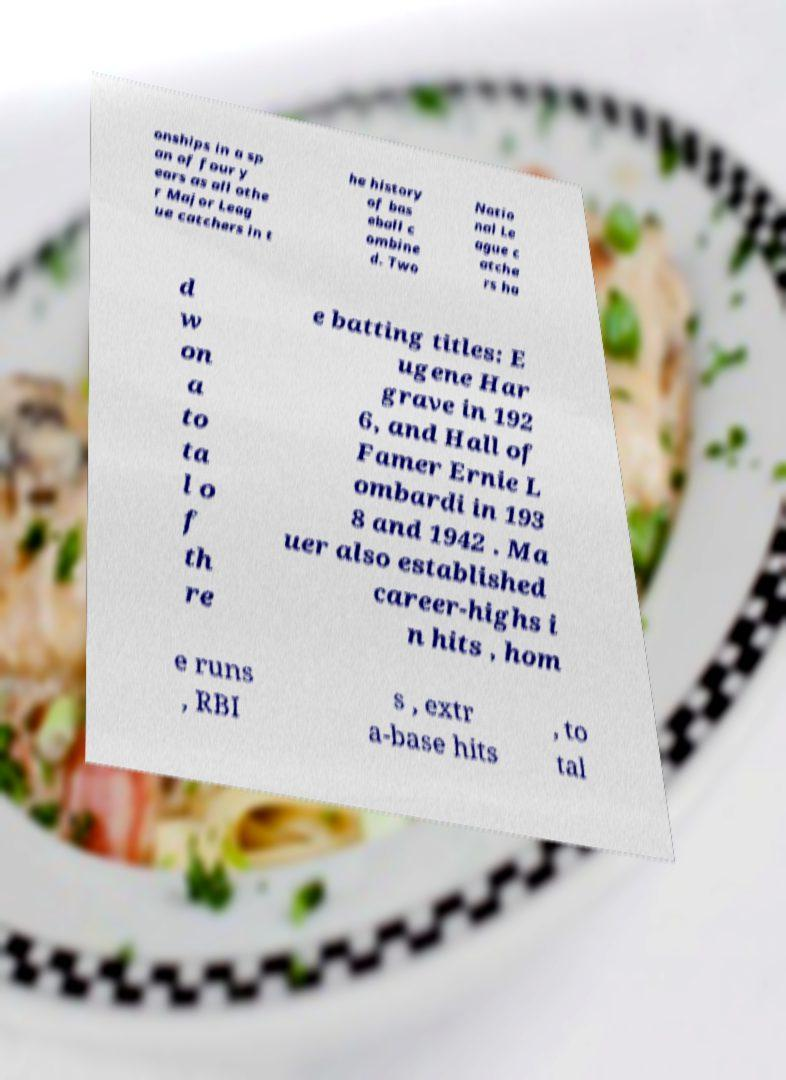Can you accurately transcribe the text from the provided image for me? onships in a sp an of four y ears as all othe r Major Leag ue catchers in t he history of bas eball c ombine d. Two Natio nal Le ague c atche rs ha d w on a to ta l o f th re e batting titles: E ugene Har grave in 192 6, and Hall of Famer Ernie L ombardi in 193 8 and 1942 . Ma uer also established career-highs i n hits , hom e runs , RBI s , extr a-base hits , to tal 